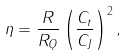Convert formula to latex. <formula><loc_0><loc_0><loc_500><loc_500>\eta = \frac { R } { R _ { Q } } \left ( \frac { C _ { t } } { C _ { J } } \right ) ^ { 2 } ,</formula> 